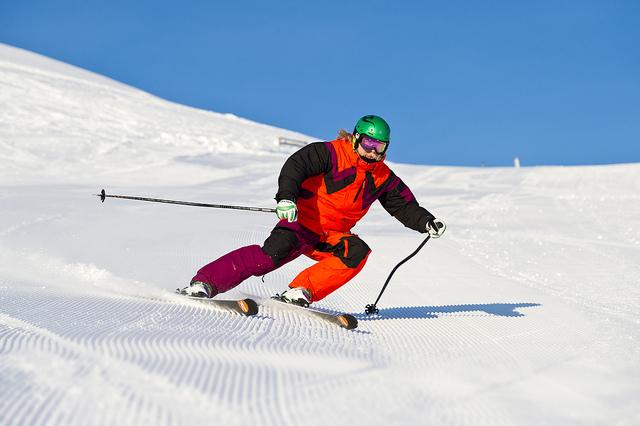If the person fell would she get wet?
Keep it brief. No. Is the skier going up or downhill?
Short answer required. Downhill. Is this person racing someone?
Quick response, please. No. Is this person color coordinated?
Be succinct. Yes. What color is the helmet?
Concise answer only. Green. What color is the jacket?
Short answer required. Orange. Is the person's clothing one color?
Answer briefly. No. 